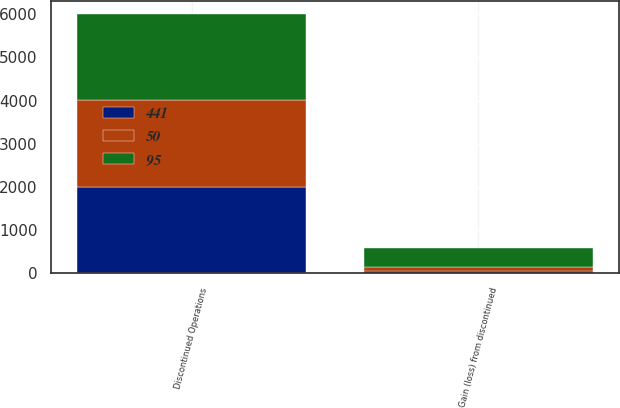Convert chart to OTSL. <chart><loc_0><loc_0><loc_500><loc_500><stacked_bar_chart><ecel><fcel>Discontinued Operations<fcel>Gain (loss) from discontinued<nl><fcel>441<fcel>2005<fcel>50<nl><fcel>50<fcel>2004<fcel>95<nl><fcel>95<fcel>2003<fcel>441<nl></chart> 